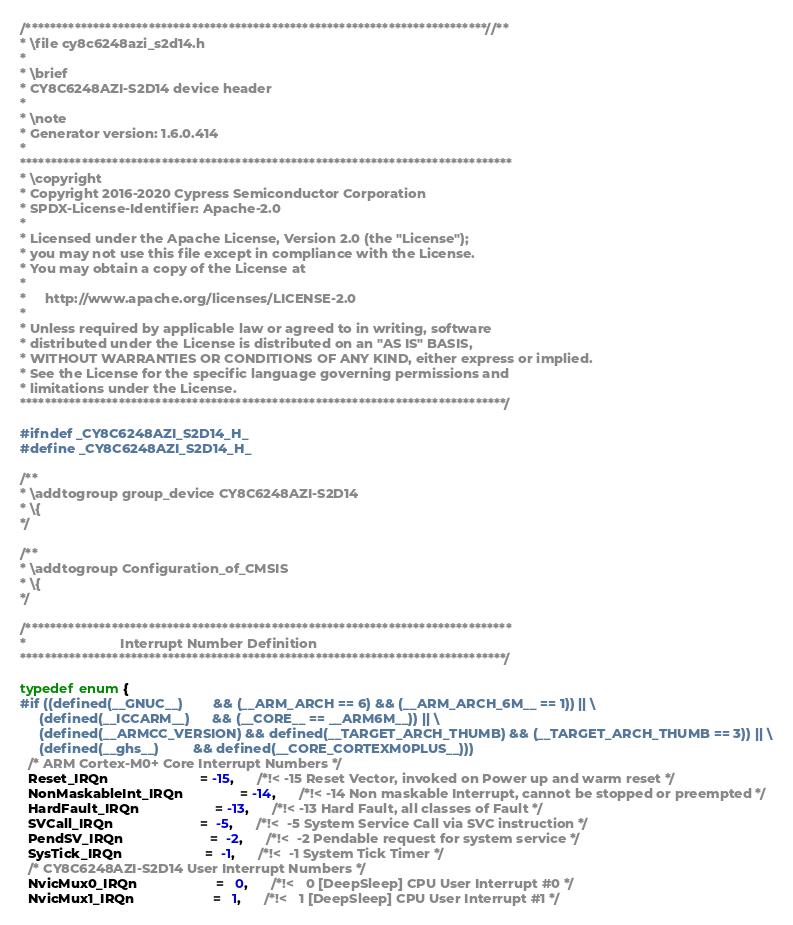<code> <loc_0><loc_0><loc_500><loc_500><_C_>/***************************************************************************//**
* \file cy8c6248azi_s2d14.h
*
* \brief
* CY8C6248AZI-S2D14 device header
*
* \note
* Generator version: 1.6.0.414
*
********************************************************************************
* \copyright
* Copyright 2016-2020 Cypress Semiconductor Corporation
* SPDX-License-Identifier: Apache-2.0
*
* Licensed under the Apache License, Version 2.0 (the "License");
* you may not use this file except in compliance with the License.
* You may obtain a copy of the License at
*
*     http://www.apache.org/licenses/LICENSE-2.0
*
* Unless required by applicable law or agreed to in writing, software
* distributed under the License is distributed on an "AS IS" BASIS,
* WITHOUT WARRANTIES OR CONDITIONS OF ANY KIND, either express or implied.
* See the License for the specific language governing permissions and
* limitations under the License.
*******************************************************************************/

#ifndef _CY8C6248AZI_S2D14_H_
#define _CY8C6248AZI_S2D14_H_

/**
* \addtogroup group_device CY8C6248AZI-S2D14
* \{
*/

/**
* \addtogroup Configuration_of_CMSIS
* \{
*/

/*******************************************************************************
*                         Interrupt Number Definition
*******************************************************************************/

typedef enum {
#if ((defined(__GNUC__)        && (__ARM_ARCH == 6) && (__ARM_ARCH_6M__ == 1)) || \
     (defined(__ICCARM__)      && (__CORE__ == __ARM6M__)) || \
     (defined(__ARMCC_VERSION) && defined(__TARGET_ARCH_THUMB) && (__TARGET_ARCH_THUMB == 3)) || \
     (defined(__ghs__)         && defined(__CORE_CORTEXM0PLUS__)))
  /* ARM Cortex-M0+ Core Interrupt Numbers */
  Reset_IRQn                        = -15,      /*!< -15 Reset Vector, invoked on Power up and warm reset */
  NonMaskableInt_IRQn               = -14,      /*!< -14 Non maskable Interrupt, cannot be stopped or preempted */
  HardFault_IRQn                    = -13,      /*!< -13 Hard Fault, all classes of Fault */
  SVCall_IRQn                       =  -5,      /*!<  -5 System Service Call via SVC instruction */
  PendSV_IRQn                       =  -2,      /*!<  -2 Pendable request for system service */
  SysTick_IRQn                      =  -1,      /*!<  -1 System Tick Timer */
  /* CY8C6248AZI-S2D14 User Interrupt Numbers */
  NvicMux0_IRQn                     =   0,      /*!<   0 [DeepSleep] CPU User Interrupt #0 */
  NvicMux1_IRQn                     =   1,      /*!<   1 [DeepSleep] CPU User Interrupt #1 */</code> 